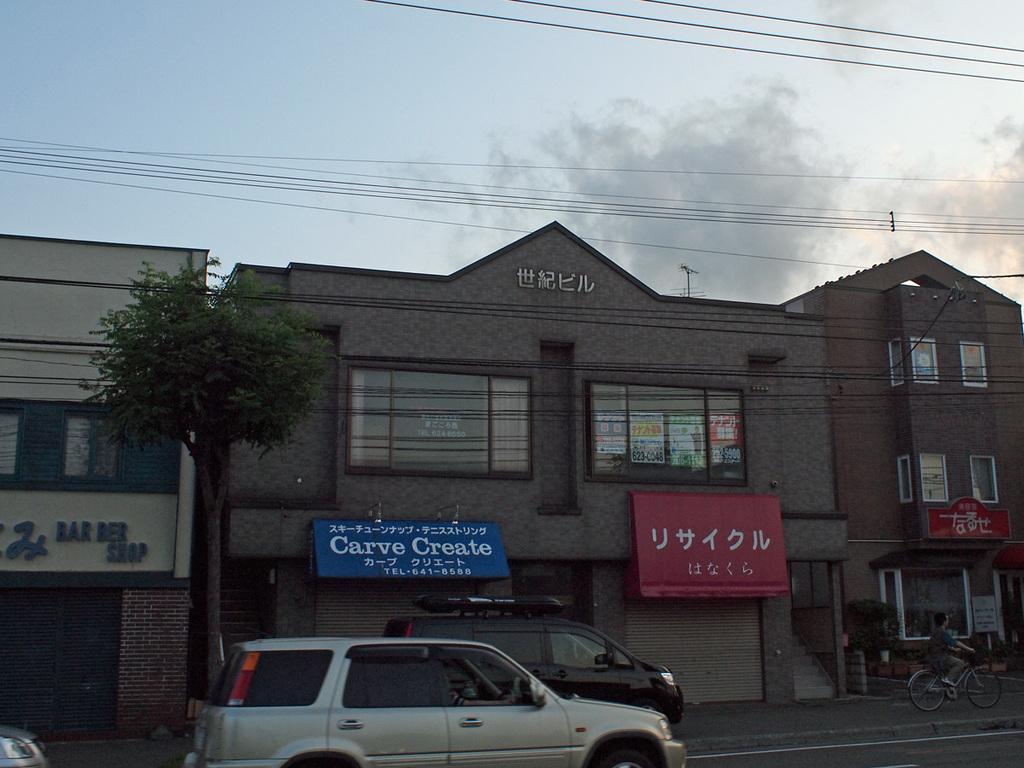Could you give a brief overview of what you see in this image? As we can see in the image there are buildings, cars, banners, tree, a person riding bicycle, windows, sky and clouds. 